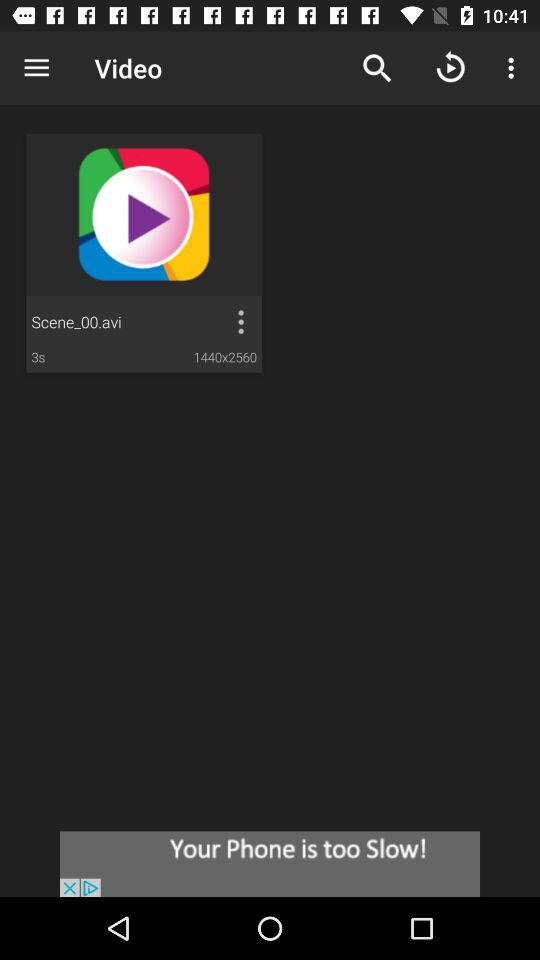What is the resolution of the video?
Answer the question using a single word or phrase. 1440x2560 